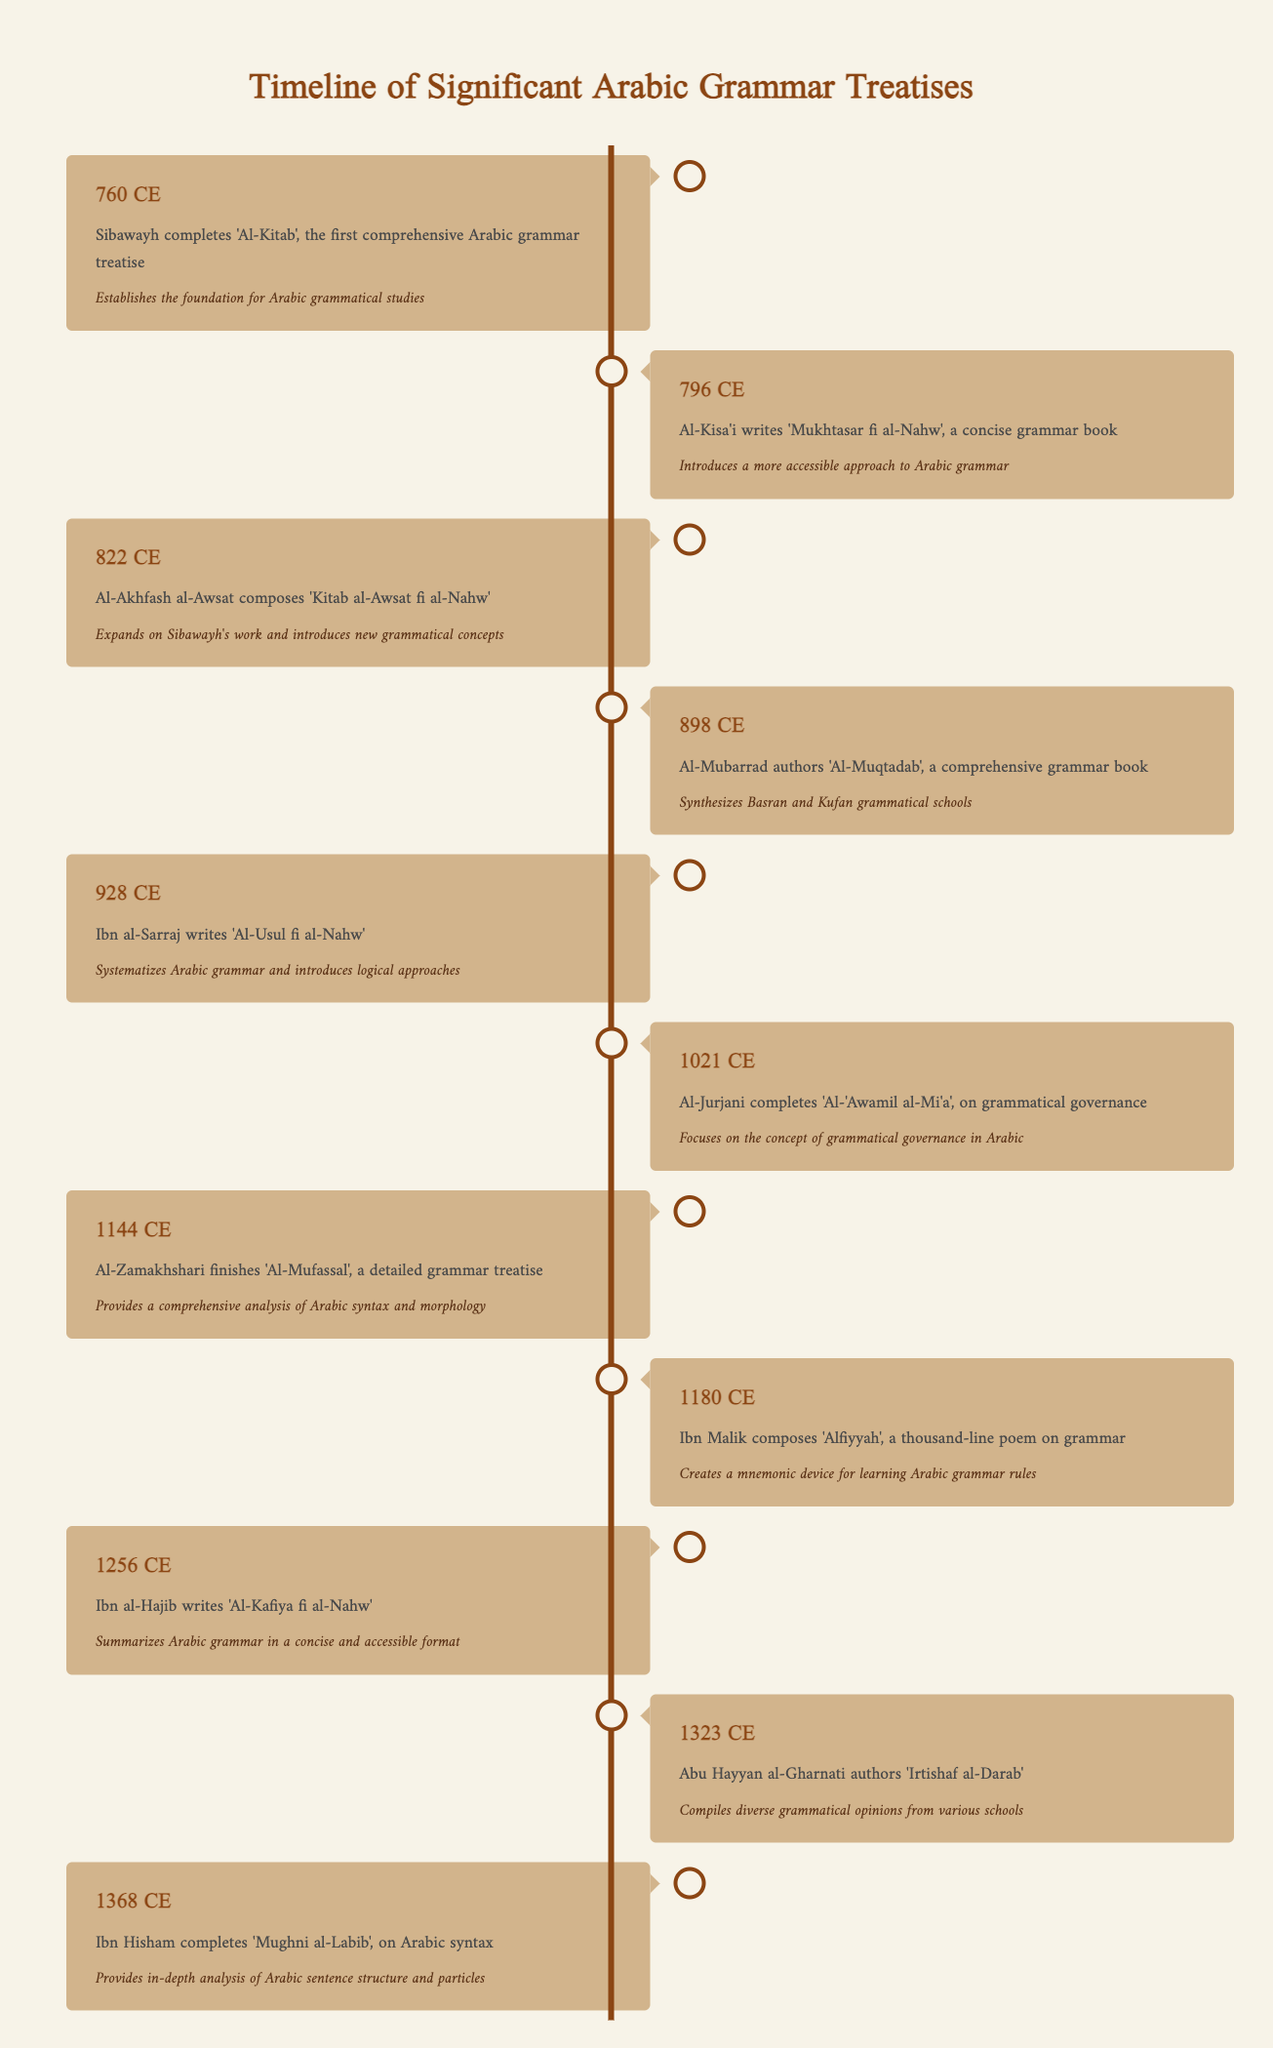What year did Sibawayh complete 'Al-Kitab'? The table indicates that Sibawayh completed 'Al-Kitab' in the year 760 CE, as stated in the first entry of the timeline.
Answer: 760 CE Which work was authored by Al-Kisa'i? According to the second entry in the timeline, Al-Kisa'i wrote 'Mukhtasar fi al-Nahw', which is the work listed for the year 796 CE.
Answer: Mukhtasar fi al-Nahw Was 'Alfiyyah' written before 1200 CE? The timeline lists 'Alfiyyah' under the year 1180 CE, which is indeed before 1200 CE. Therefore, the statement is true.
Answer: Yes How many significant grammar treatises are mentioned between 800 and 900 CE? The entries for this range show three grammar treatises: 796 CE (Al-Kisa'i), 822 CE (Al-Akhfash al-Awsat), and 898 CE (Al-Mubarrad). Thus, the count is three.
Answer: 3 What are the last two works listed in the timeline, and what years were they completed? The last two entries are for 1323 CE (Abu Hayyan al-Gharnati's 'Irtishaf al-Darab') and 1368 CE (Ibn Hisham's 'Mughni al-Labib'). This conveys their respective years of completion.
Answer: Irtishaf al-Darab in 1323 CE, Mughni al-Labib in 1368 CE Which treatise synthesized Basran and Kufan grammatical schools? The table shows that 'Al-Muqtadab' authored by Al-Mubarrad in 898 CE is the treatise known for synthesizing these two grammatical schools.
Answer: Al-Muqtadab Which grammar work focused on grammatical governance? According to the timeline, Al-Jurjani completed 'Al-'Awamil al-Mi'a' in 1021 CE, focusing specifically on grammatical governance in Arabic.
Answer: Al-'Awamil al-Mi'a How many years apart were 'Alfiyyah' and 'Al-Kafiya fi al-Nahw'? 'Alfiyyah' was completed in 1180 CE, and 'Al-Kafiya fi al-Nahw' was written in 1256 CE. The difference is 1256 - 1180 = 76 years.
Answer: 76 years 